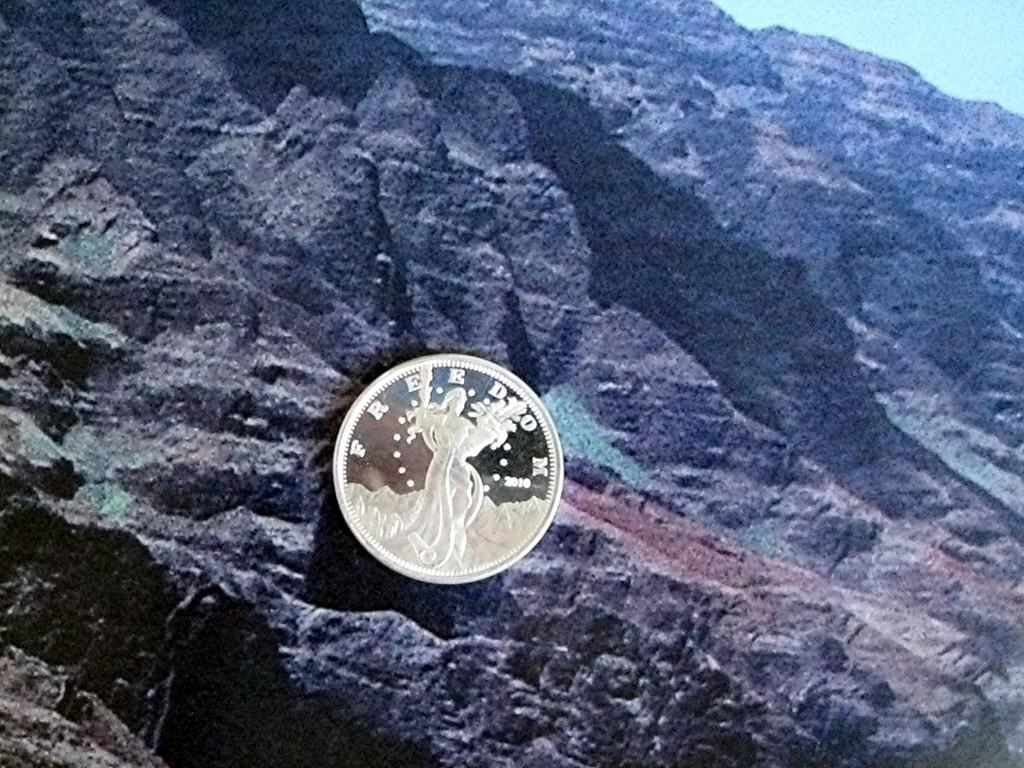<image>
Present a compact description of the photo's key features. A coin labeled freedom that was minted in 2010. 